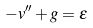<formula> <loc_0><loc_0><loc_500><loc_500>- v ^ { \prime \prime } + g = \epsilon</formula> 